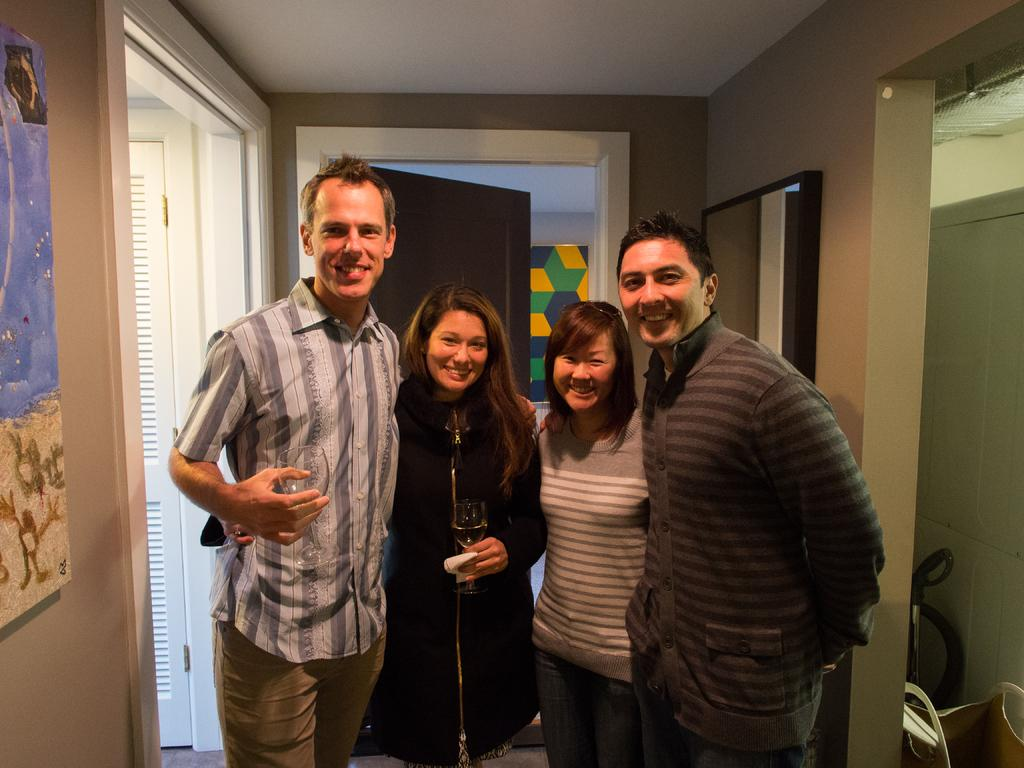What can be observed about the attire of the people in the image? There are people wearing different color dresses in the image. What architectural features can be seen in the background of the image? There are doors and boards attached to the wall visible in the background of the image. What objects are being held by some people in the image? Some people are holding glasses in the image. Can you see any smoke coming from the ear of the person in the image? There is no smoke coming from the ear of any person in the image, nor is there any indication of such an occurrence. 